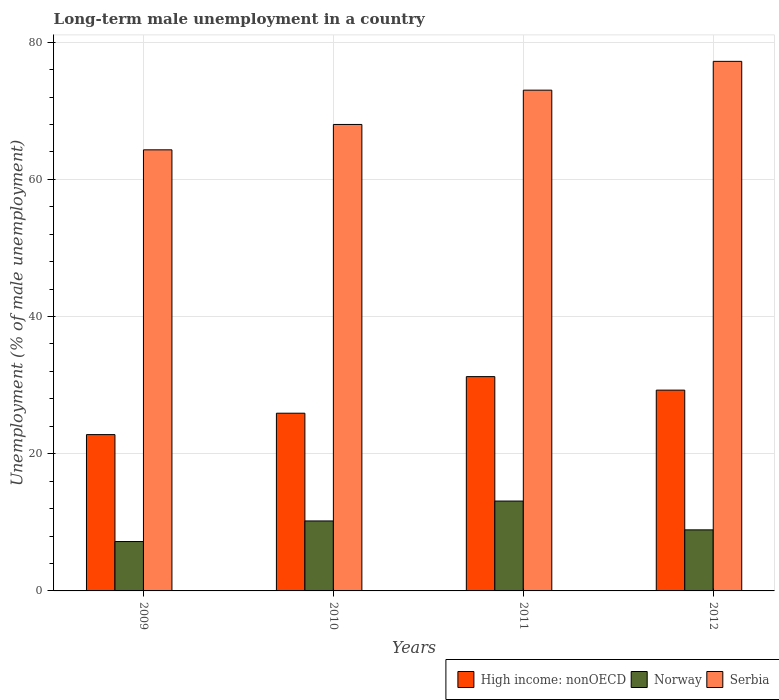What is the label of the 4th group of bars from the left?
Offer a terse response. 2012. What is the percentage of long-term unemployed male population in Norway in 2011?
Give a very brief answer. 13.1. Across all years, what is the maximum percentage of long-term unemployed male population in Norway?
Make the answer very short. 13.1. Across all years, what is the minimum percentage of long-term unemployed male population in Serbia?
Provide a short and direct response. 64.3. What is the total percentage of long-term unemployed male population in High income: nonOECD in the graph?
Ensure brevity in your answer.  109.2. What is the difference between the percentage of long-term unemployed male population in Norway in 2009 and that in 2011?
Give a very brief answer. -5.9. What is the difference between the percentage of long-term unemployed male population in High income: nonOECD in 2011 and the percentage of long-term unemployed male population in Serbia in 2009?
Offer a very short reply. -33.06. What is the average percentage of long-term unemployed male population in High income: nonOECD per year?
Provide a short and direct response. 27.3. In the year 2009, what is the difference between the percentage of long-term unemployed male population in Norway and percentage of long-term unemployed male population in Serbia?
Your answer should be very brief. -57.1. In how many years, is the percentage of long-term unemployed male population in Serbia greater than 4 %?
Your answer should be very brief. 4. What is the ratio of the percentage of long-term unemployed male population in Norway in 2011 to that in 2012?
Ensure brevity in your answer.  1.47. What is the difference between the highest and the second highest percentage of long-term unemployed male population in High income: nonOECD?
Keep it short and to the point. 1.97. What is the difference between the highest and the lowest percentage of long-term unemployed male population in Norway?
Ensure brevity in your answer.  5.9. What does the 2nd bar from the left in 2011 represents?
Keep it short and to the point. Norway. What does the 3rd bar from the right in 2010 represents?
Your answer should be compact. High income: nonOECD. Is it the case that in every year, the sum of the percentage of long-term unemployed male population in Serbia and percentage of long-term unemployed male population in Norway is greater than the percentage of long-term unemployed male population in High income: nonOECD?
Ensure brevity in your answer.  Yes. How many years are there in the graph?
Provide a succinct answer. 4. Does the graph contain grids?
Your answer should be very brief. Yes. Where does the legend appear in the graph?
Provide a succinct answer. Bottom right. How many legend labels are there?
Make the answer very short. 3. How are the legend labels stacked?
Your answer should be compact. Horizontal. What is the title of the graph?
Keep it short and to the point. Long-term male unemployment in a country. What is the label or title of the X-axis?
Your answer should be compact. Years. What is the label or title of the Y-axis?
Provide a succinct answer. Unemployment (% of male unemployment). What is the Unemployment (% of male unemployment) of High income: nonOECD in 2009?
Ensure brevity in your answer.  22.79. What is the Unemployment (% of male unemployment) in Norway in 2009?
Your answer should be compact. 7.2. What is the Unemployment (% of male unemployment) in Serbia in 2009?
Offer a terse response. 64.3. What is the Unemployment (% of male unemployment) in High income: nonOECD in 2010?
Give a very brief answer. 25.91. What is the Unemployment (% of male unemployment) of Norway in 2010?
Provide a succinct answer. 10.2. What is the Unemployment (% of male unemployment) of High income: nonOECD in 2011?
Provide a succinct answer. 31.24. What is the Unemployment (% of male unemployment) in Norway in 2011?
Keep it short and to the point. 13.1. What is the Unemployment (% of male unemployment) in High income: nonOECD in 2012?
Offer a very short reply. 29.27. What is the Unemployment (% of male unemployment) in Norway in 2012?
Offer a very short reply. 8.9. What is the Unemployment (% of male unemployment) of Serbia in 2012?
Ensure brevity in your answer.  77.2. Across all years, what is the maximum Unemployment (% of male unemployment) in High income: nonOECD?
Keep it short and to the point. 31.24. Across all years, what is the maximum Unemployment (% of male unemployment) in Norway?
Give a very brief answer. 13.1. Across all years, what is the maximum Unemployment (% of male unemployment) in Serbia?
Offer a very short reply. 77.2. Across all years, what is the minimum Unemployment (% of male unemployment) of High income: nonOECD?
Make the answer very short. 22.79. Across all years, what is the minimum Unemployment (% of male unemployment) in Norway?
Provide a short and direct response. 7.2. Across all years, what is the minimum Unemployment (% of male unemployment) of Serbia?
Provide a succinct answer. 64.3. What is the total Unemployment (% of male unemployment) in High income: nonOECD in the graph?
Offer a very short reply. 109.2. What is the total Unemployment (% of male unemployment) in Norway in the graph?
Provide a succinct answer. 39.4. What is the total Unemployment (% of male unemployment) in Serbia in the graph?
Offer a very short reply. 282.5. What is the difference between the Unemployment (% of male unemployment) in High income: nonOECD in 2009 and that in 2010?
Your response must be concise. -3.12. What is the difference between the Unemployment (% of male unemployment) in Norway in 2009 and that in 2010?
Provide a succinct answer. -3. What is the difference between the Unemployment (% of male unemployment) in Serbia in 2009 and that in 2010?
Give a very brief answer. -3.7. What is the difference between the Unemployment (% of male unemployment) of High income: nonOECD in 2009 and that in 2011?
Offer a very short reply. -8.45. What is the difference between the Unemployment (% of male unemployment) of High income: nonOECD in 2009 and that in 2012?
Make the answer very short. -6.48. What is the difference between the Unemployment (% of male unemployment) of Serbia in 2009 and that in 2012?
Your answer should be compact. -12.9. What is the difference between the Unemployment (% of male unemployment) in High income: nonOECD in 2010 and that in 2011?
Offer a terse response. -5.34. What is the difference between the Unemployment (% of male unemployment) in Serbia in 2010 and that in 2011?
Offer a very short reply. -5. What is the difference between the Unemployment (% of male unemployment) in High income: nonOECD in 2010 and that in 2012?
Your answer should be compact. -3.36. What is the difference between the Unemployment (% of male unemployment) of Norway in 2010 and that in 2012?
Your answer should be compact. 1.3. What is the difference between the Unemployment (% of male unemployment) of Serbia in 2010 and that in 2012?
Give a very brief answer. -9.2. What is the difference between the Unemployment (% of male unemployment) in High income: nonOECD in 2011 and that in 2012?
Your answer should be very brief. 1.97. What is the difference between the Unemployment (% of male unemployment) of Norway in 2011 and that in 2012?
Offer a very short reply. 4.2. What is the difference between the Unemployment (% of male unemployment) in Serbia in 2011 and that in 2012?
Offer a very short reply. -4.2. What is the difference between the Unemployment (% of male unemployment) of High income: nonOECD in 2009 and the Unemployment (% of male unemployment) of Norway in 2010?
Offer a very short reply. 12.59. What is the difference between the Unemployment (% of male unemployment) in High income: nonOECD in 2009 and the Unemployment (% of male unemployment) in Serbia in 2010?
Offer a very short reply. -45.21. What is the difference between the Unemployment (% of male unemployment) of Norway in 2009 and the Unemployment (% of male unemployment) of Serbia in 2010?
Keep it short and to the point. -60.8. What is the difference between the Unemployment (% of male unemployment) in High income: nonOECD in 2009 and the Unemployment (% of male unemployment) in Norway in 2011?
Your response must be concise. 9.69. What is the difference between the Unemployment (% of male unemployment) of High income: nonOECD in 2009 and the Unemployment (% of male unemployment) of Serbia in 2011?
Offer a terse response. -50.21. What is the difference between the Unemployment (% of male unemployment) in Norway in 2009 and the Unemployment (% of male unemployment) in Serbia in 2011?
Your answer should be very brief. -65.8. What is the difference between the Unemployment (% of male unemployment) of High income: nonOECD in 2009 and the Unemployment (% of male unemployment) of Norway in 2012?
Keep it short and to the point. 13.89. What is the difference between the Unemployment (% of male unemployment) of High income: nonOECD in 2009 and the Unemployment (% of male unemployment) of Serbia in 2012?
Keep it short and to the point. -54.41. What is the difference between the Unemployment (% of male unemployment) in Norway in 2009 and the Unemployment (% of male unemployment) in Serbia in 2012?
Ensure brevity in your answer.  -70. What is the difference between the Unemployment (% of male unemployment) in High income: nonOECD in 2010 and the Unemployment (% of male unemployment) in Norway in 2011?
Offer a very short reply. 12.81. What is the difference between the Unemployment (% of male unemployment) in High income: nonOECD in 2010 and the Unemployment (% of male unemployment) in Serbia in 2011?
Keep it short and to the point. -47.09. What is the difference between the Unemployment (% of male unemployment) in Norway in 2010 and the Unemployment (% of male unemployment) in Serbia in 2011?
Your answer should be compact. -62.8. What is the difference between the Unemployment (% of male unemployment) in High income: nonOECD in 2010 and the Unemployment (% of male unemployment) in Norway in 2012?
Your response must be concise. 17.01. What is the difference between the Unemployment (% of male unemployment) in High income: nonOECD in 2010 and the Unemployment (% of male unemployment) in Serbia in 2012?
Ensure brevity in your answer.  -51.29. What is the difference between the Unemployment (% of male unemployment) in Norway in 2010 and the Unemployment (% of male unemployment) in Serbia in 2012?
Make the answer very short. -67. What is the difference between the Unemployment (% of male unemployment) in High income: nonOECD in 2011 and the Unemployment (% of male unemployment) in Norway in 2012?
Offer a terse response. 22.34. What is the difference between the Unemployment (% of male unemployment) of High income: nonOECD in 2011 and the Unemployment (% of male unemployment) of Serbia in 2012?
Ensure brevity in your answer.  -45.96. What is the difference between the Unemployment (% of male unemployment) of Norway in 2011 and the Unemployment (% of male unemployment) of Serbia in 2012?
Provide a succinct answer. -64.1. What is the average Unemployment (% of male unemployment) in High income: nonOECD per year?
Your response must be concise. 27.3. What is the average Unemployment (% of male unemployment) in Norway per year?
Keep it short and to the point. 9.85. What is the average Unemployment (% of male unemployment) in Serbia per year?
Provide a short and direct response. 70.62. In the year 2009, what is the difference between the Unemployment (% of male unemployment) in High income: nonOECD and Unemployment (% of male unemployment) in Norway?
Make the answer very short. 15.59. In the year 2009, what is the difference between the Unemployment (% of male unemployment) of High income: nonOECD and Unemployment (% of male unemployment) of Serbia?
Keep it short and to the point. -41.51. In the year 2009, what is the difference between the Unemployment (% of male unemployment) in Norway and Unemployment (% of male unemployment) in Serbia?
Make the answer very short. -57.1. In the year 2010, what is the difference between the Unemployment (% of male unemployment) of High income: nonOECD and Unemployment (% of male unemployment) of Norway?
Offer a terse response. 15.71. In the year 2010, what is the difference between the Unemployment (% of male unemployment) of High income: nonOECD and Unemployment (% of male unemployment) of Serbia?
Ensure brevity in your answer.  -42.09. In the year 2010, what is the difference between the Unemployment (% of male unemployment) in Norway and Unemployment (% of male unemployment) in Serbia?
Offer a very short reply. -57.8. In the year 2011, what is the difference between the Unemployment (% of male unemployment) in High income: nonOECD and Unemployment (% of male unemployment) in Norway?
Your answer should be compact. 18.14. In the year 2011, what is the difference between the Unemployment (% of male unemployment) in High income: nonOECD and Unemployment (% of male unemployment) in Serbia?
Your answer should be compact. -41.76. In the year 2011, what is the difference between the Unemployment (% of male unemployment) in Norway and Unemployment (% of male unemployment) in Serbia?
Provide a short and direct response. -59.9. In the year 2012, what is the difference between the Unemployment (% of male unemployment) of High income: nonOECD and Unemployment (% of male unemployment) of Norway?
Offer a very short reply. 20.37. In the year 2012, what is the difference between the Unemployment (% of male unemployment) of High income: nonOECD and Unemployment (% of male unemployment) of Serbia?
Make the answer very short. -47.93. In the year 2012, what is the difference between the Unemployment (% of male unemployment) in Norway and Unemployment (% of male unemployment) in Serbia?
Your answer should be compact. -68.3. What is the ratio of the Unemployment (% of male unemployment) in High income: nonOECD in 2009 to that in 2010?
Make the answer very short. 0.88. What is the ratio of the Unemployment (% of male unemployment) of Norway in 2009 to that in 2010?
Ensure brevity in your answer.  0.71. What is the ratio of the Unemployment (% of male unemployment) of Serbia in 2009 to that in 2010?
Your answer should be compact. 0.95. What is the ratio of the Unemployment (% of male unemployment) of High income: nonOECD in 2009 to that in 2011?
Your answer should be compact. 0.73. What is the ratio of the Unemployment (% of male unemployment) of Norway in 2009 to that in 2011?
Provide a short and direct response. 0.55. What is the ratio of the Unemployment (% of male unemployment) in Serbia in 2009 to that in 2011?
Offer a very short reply. 0.88. What is the ratio of the Unemployment (% of male unemployment) of High income: nonOECD in 2009 to that in 2012?
Give a very brief answer. 0.78. What is the ratio of the Unemployment (% of male unemployment) of Norway in 2009 to that in 2012?
Your answer should be compact. 0.81. What is the ratio of the Unemployment (% of male unemployment) of Serbia in 2009 to that in 2012?
Your answer should be very brief. 0.83. What is the ratio of the Unemployment (% of male unemployment) of High income: nonOECD in 2010 to that in 2011?
Offer a terse response. 0.83. What is the ratio of the Unemployment (% of male unemployment) in Norway in 2010 to that in 2011?
Offer a terse response. 0.78. What is the ratio of the Unemployment (% of male unemployment) in Serbia in 2010 to that in 2011?
Offer a terse response. 0.93. What is the ratio of the Unemployment (% of male unemployment) in High income: nonOECD in 2010 to that in 2012?
Offer a terse response. 0.89. What is the ratio of the Unemployment (% of male unemployment) of Norway in 2010 to that in 2012?
Give a very brief answer. 1.15. What is the ratio of the Unemployment (% of male unemployment) of Serbia in 2010 to that in 2012?
Give a very brief answer. 0.88. What is the ratio of the Unemployment (% of male unemployment) of High income: nonOECD in 2011 to that in 2012?
Make the answer very short. 1.07. What is the ratio of the Unemployment (% of male unemployment) in Norway in 2011 to that in 2012?
Ensure brevity in your answer.  1.47. What is the ratio of the Unemployment (% of male unemployment) of Serbia in 2011 to that in 2012?
Your answer should be very brief. 0.95. What is the difference between the highest and the second highest Unemployment (% of male unemployment) of High income: nonOECD?
Your answer should be very brief. 1.97. What is the difference between the highest and the lowest Unemployment (% of male unemployment) of High income: nonOECD?
Your answer should be very brief. 8.45. 